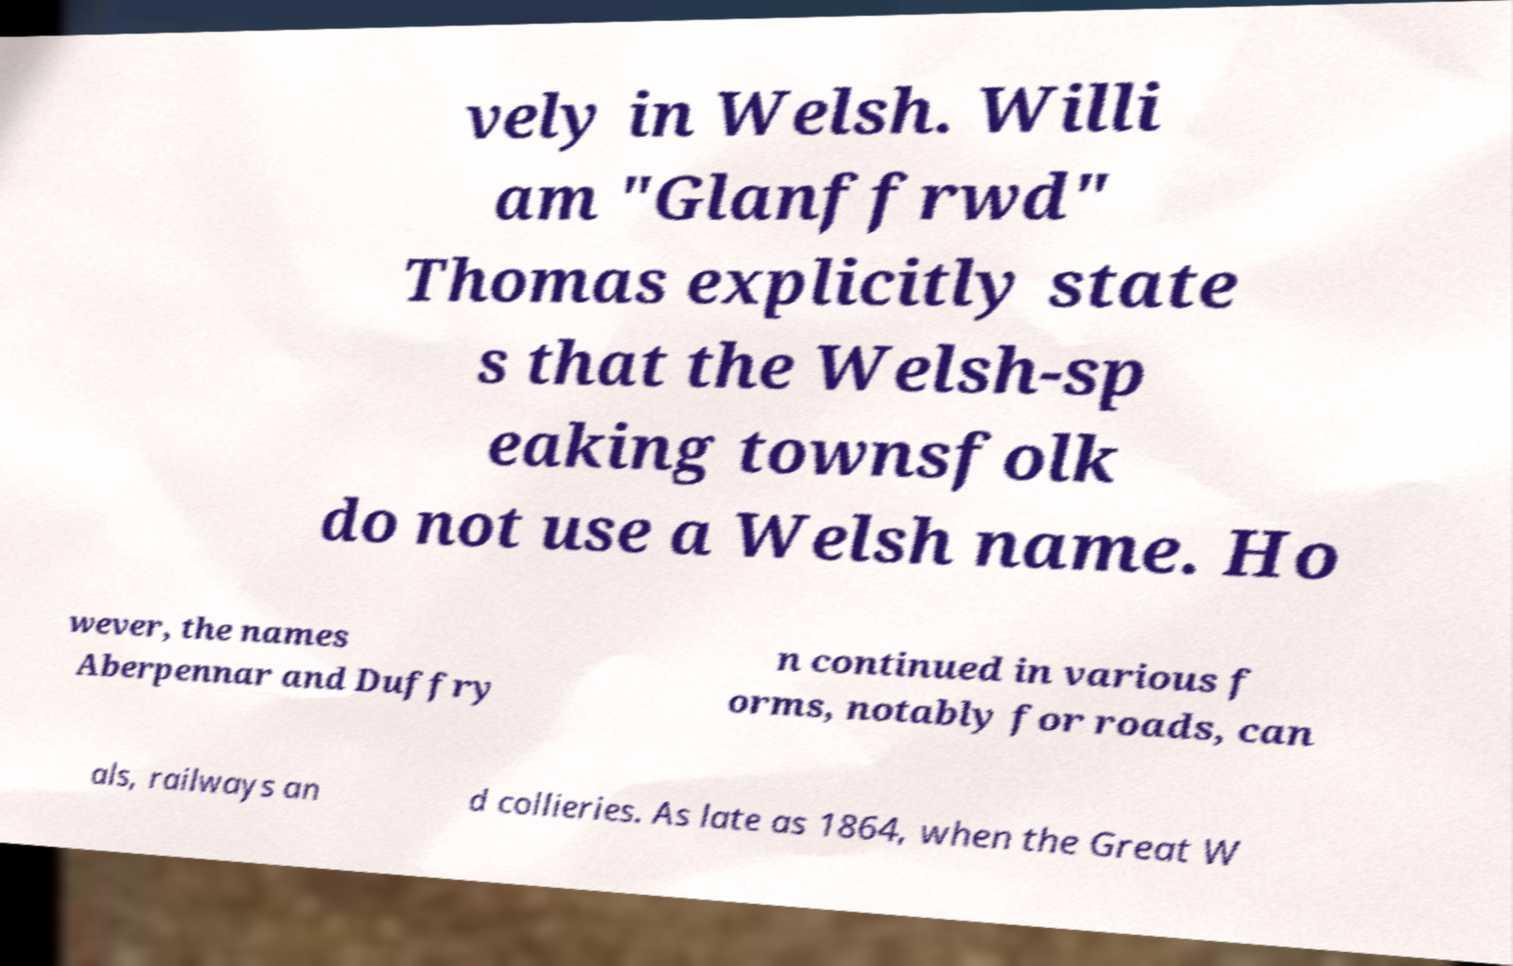Can you accurately transcribe the text from the provided image for me? vely in Welsh. Willi am "Glanffrwd" Thomas explicitly state s that the Welsh-sp eaking townsfolk do not use a Welsh name. Ho wever, the names Aberpennar and Duffry n continued in various f orms, notably for roads, can als, railways an d collieries. As late as 1864, when the Great W 